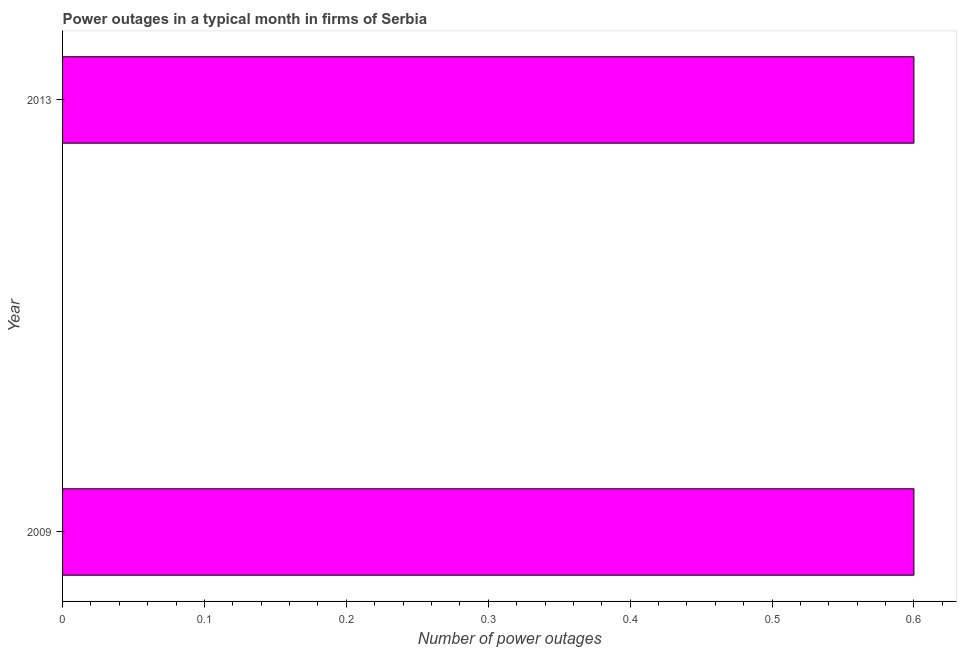Does the graph contain grids?
Ensure brevity in your answer.  No. What is the title of the graph?
Your response must be concise. Power outages in a typical month in firms of Serbia. What is the label or title of the X-axis?
Keep it short and to the point. Number of power outages. Across all years, what is the minimum number of power outages?
Make the answer very short. 0.6. In which year was the number of power outages maximum?
Offer a very short reply. 2009. In which year was the number of power outages minimum?
Your answer should be very brief. 2009. What is the median number of power outages?
Your answer should be compact. 0.6. Do a majority of the years between 2009 and 2013 (inclusive) have number of power outages greater than 0.6 ?
Offer a very short reply. No. In how many years, is the number of power outages greater than the average number of power outages taken over all years?
Your answer should be compact. 0. Are all the bars in the graph horizontal?
Give a very brief answer. Yes. Are the values on the major ticks of X-axis written in scientific E-notation?
Your answer should be very brief. No. 